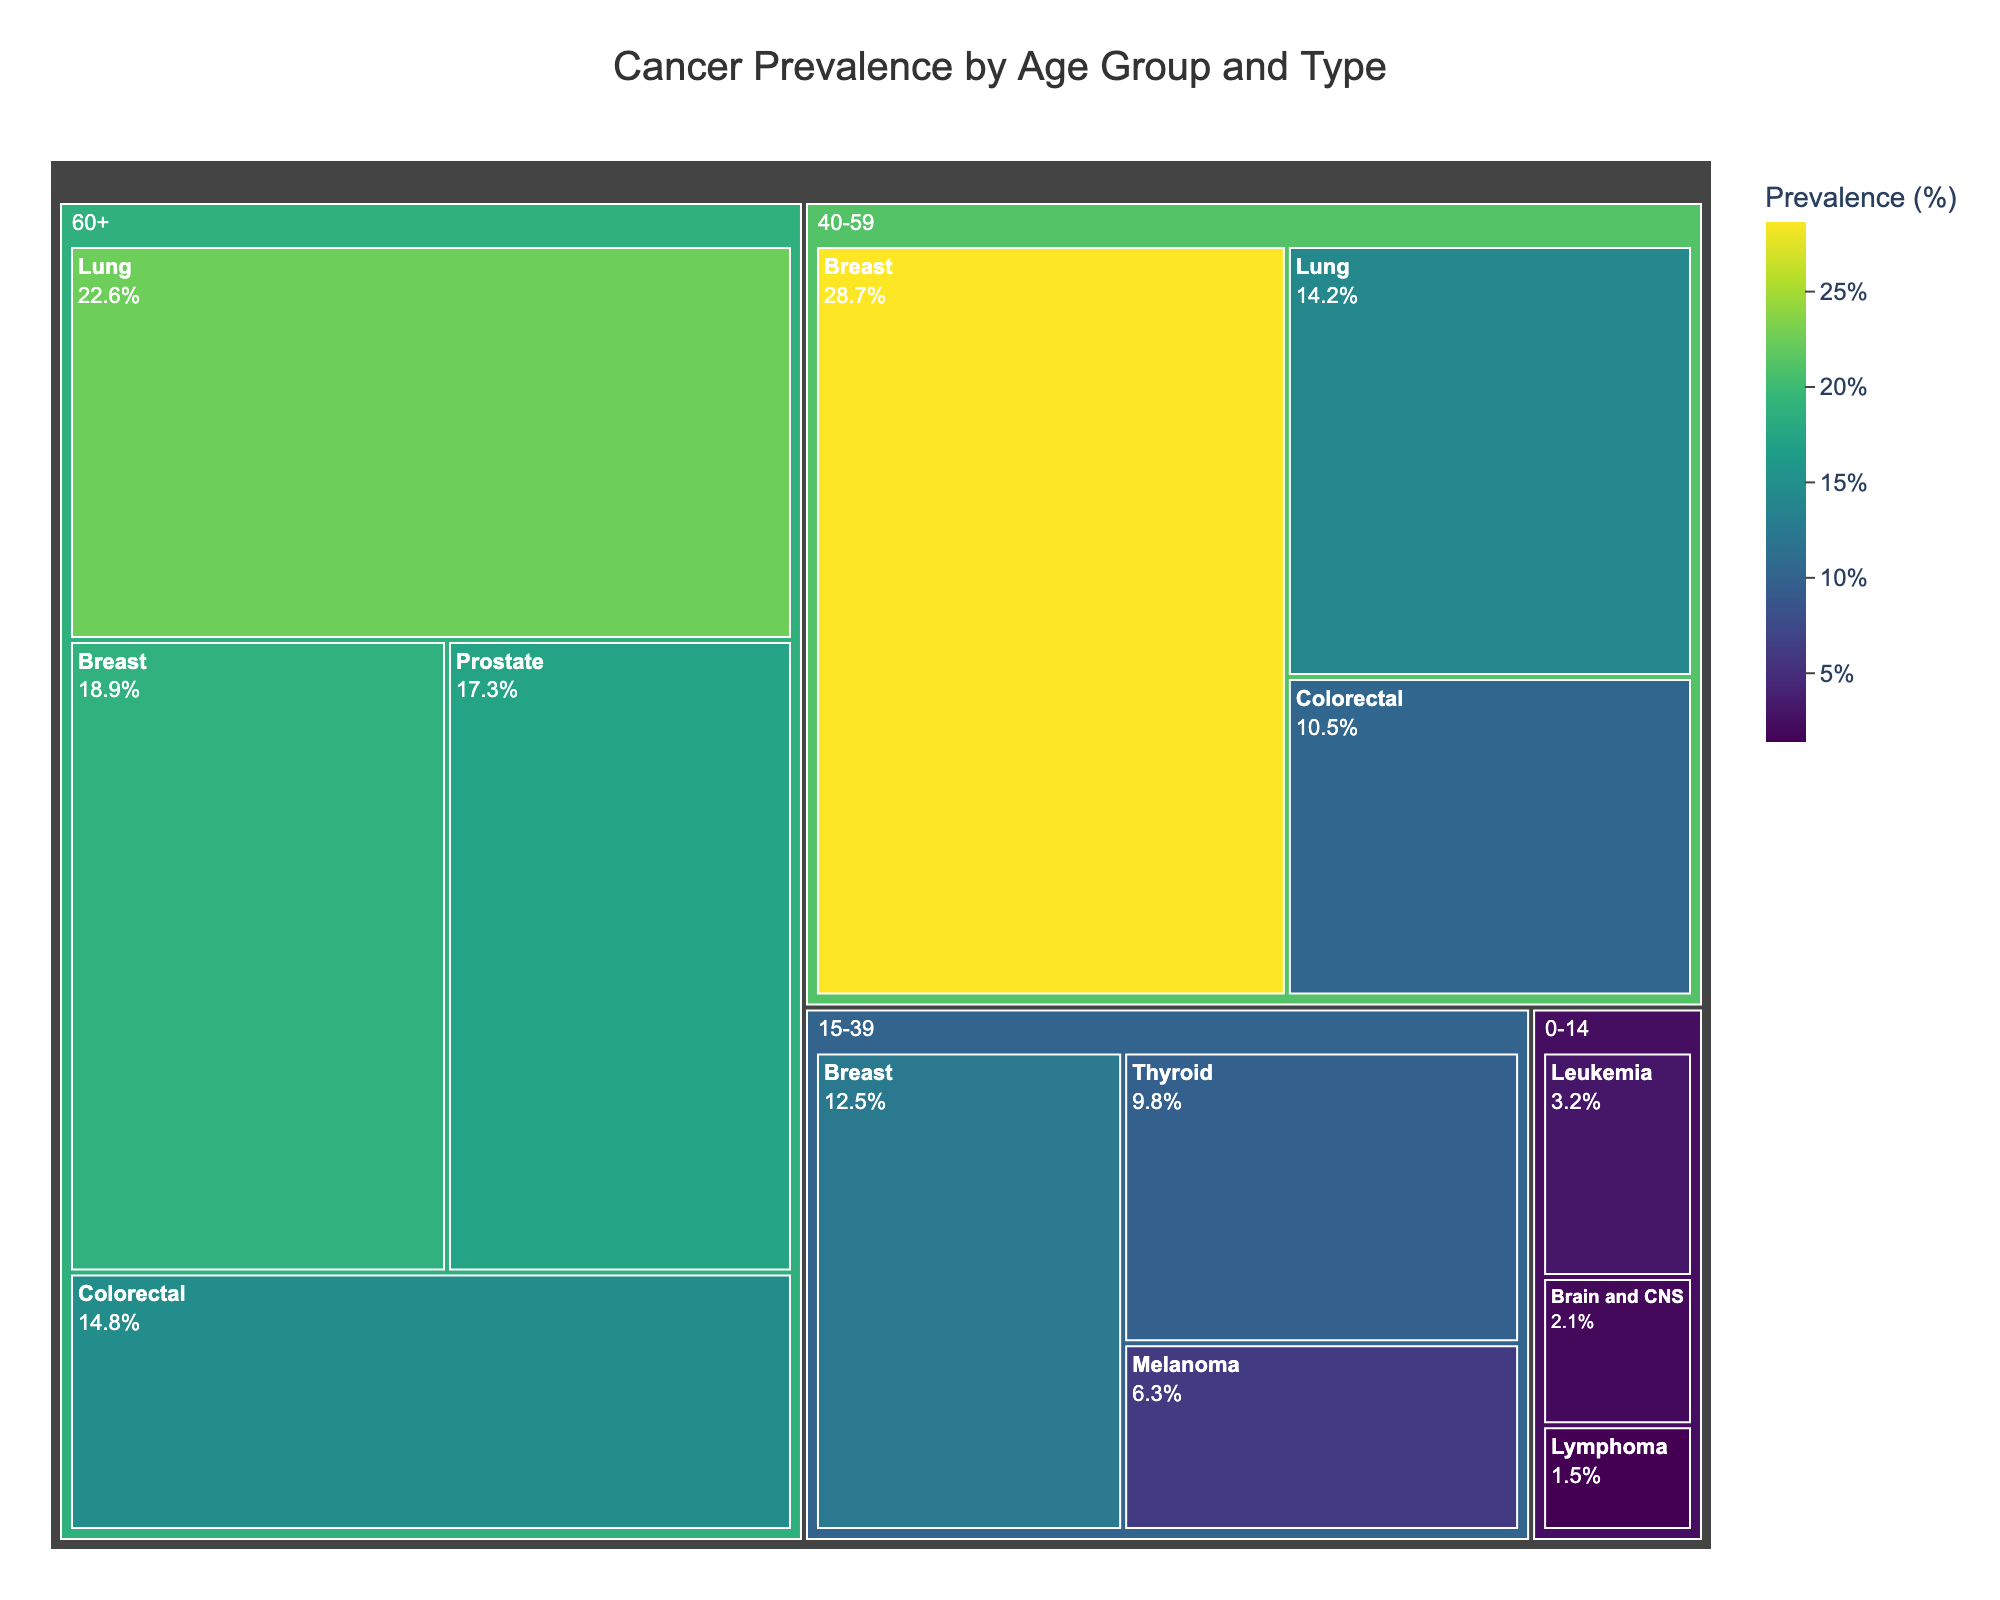Which age group has the highest prevalence of Lung cancer? By examining the Treemap, the 60+ age group has the highest prevalence of Lung cancer shown by the size and color intensity of the corresponding tile.
Answer: 60+ What is the title of the figure? The title is displayed at the top of the figure.
Answer: Cancer Prevalence by Age Group and Type How does the prevalence of Breast cancer in the 40-59 age group compare to the 60+ age group? Check the size and color intensity of the tiles labeled "Breast" in the 40-59 and 60+ age groups. The tile for the 40-59 age group appears larger and more intense compared to the 60+ age group.
Answer: Higher in 40-59 age group What is the combined prevalence of Colorectal cancer for all age groups? Sum the prevalence values of Colorectal cancer across 40-59 and 60+ age groups: 10.5% (40-59) + 14.8% (60+) = 25.3%.
Answer: 25.3% Which cancer type has the lowest prevalence in the 15-39 age group? Compare the size and color intensity of the tiles within the 15-39 age group. The tile labeled "Melanoma" has the lowest prevalence with 6.3%.
Answer: Melanoma What is the most common cancer type for the 0-14 age group? By looking at the size and color intensity of the tiles in the 0-14 age group, the "Leukemia" tile is the largest and most intense.
Answer: Leukemia Compare the prevalence of Lung cancer in the 40-59 age group with Breast cancer in the 15-39 age group. Which is higher? Examine the prevalence values of both. Lung cancer in the 40-59 age group has a prevalence of 14.2%, while Breast cancer in the 15-39 age group has 12.5%. Therefore, Lung cancer is higher.
Answer: Lung cancer in 40-59 age group How many age groups have Prostate cancer data available? Identify the tiles labeled "Prostate" in the Treemap, which appears only in the 60+ age group.
Answer: 1 age group What is the prevalence difference between Thyroid cancer in the 15-39 age group and Brain and CNS cancer in the 0-14 age group? Subtract the prevalence of Brain and CNS cancer (2.1%) from the prevalence of Thyroid cancer (9.8%): 9.8% - 2.1% = 7.7%.
Answer: 7.7% Which cancer types are present in the 60+ age group? Identify and list the tiles in the 60+ age group: Lung, Breast, Prostate, Colorectal.
Answer: Lung, Breast, Prostate, Colorectal 